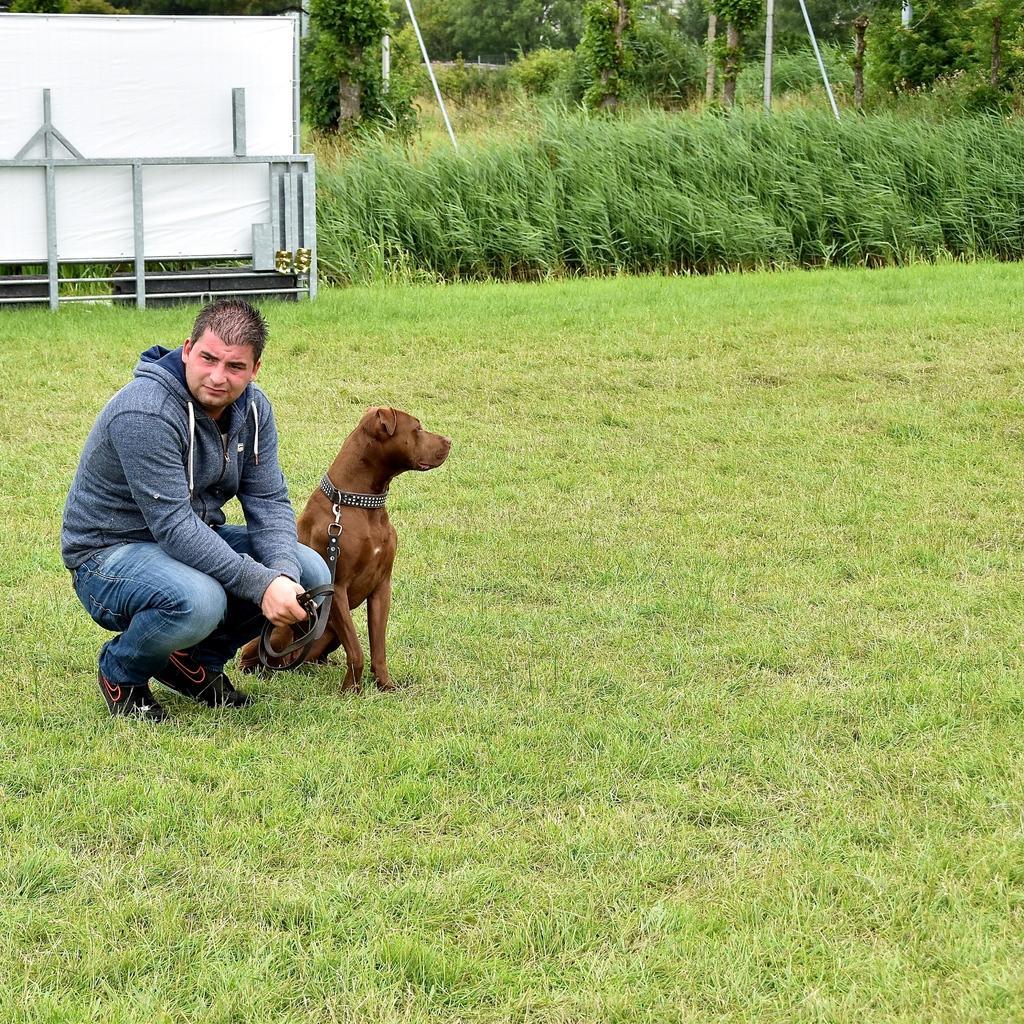Please provide a concise description of this image. In this picture we can see a man on the ground. This is dog. Here we can see some plants and there are trees. 